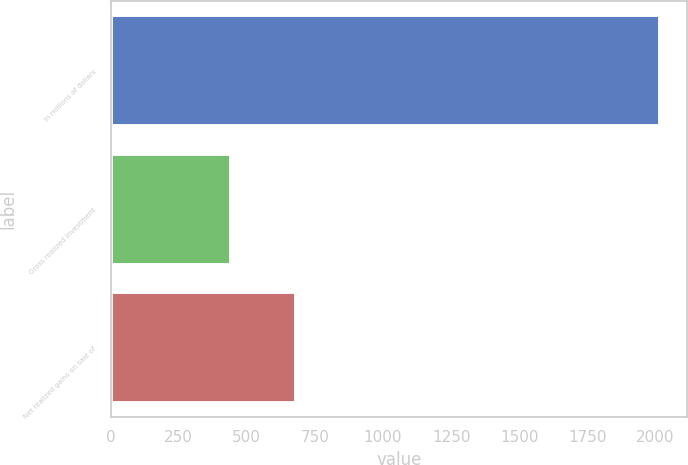<chart> <loc_0><loc_0><loc_500><loc_500><bar_chart><fcel>In millions of dollars<fcel>Gross realized investment<fcel>Net realized gains on sale of<nl><fcel>2015<fcel>442<fcel>682<nl></chart> 